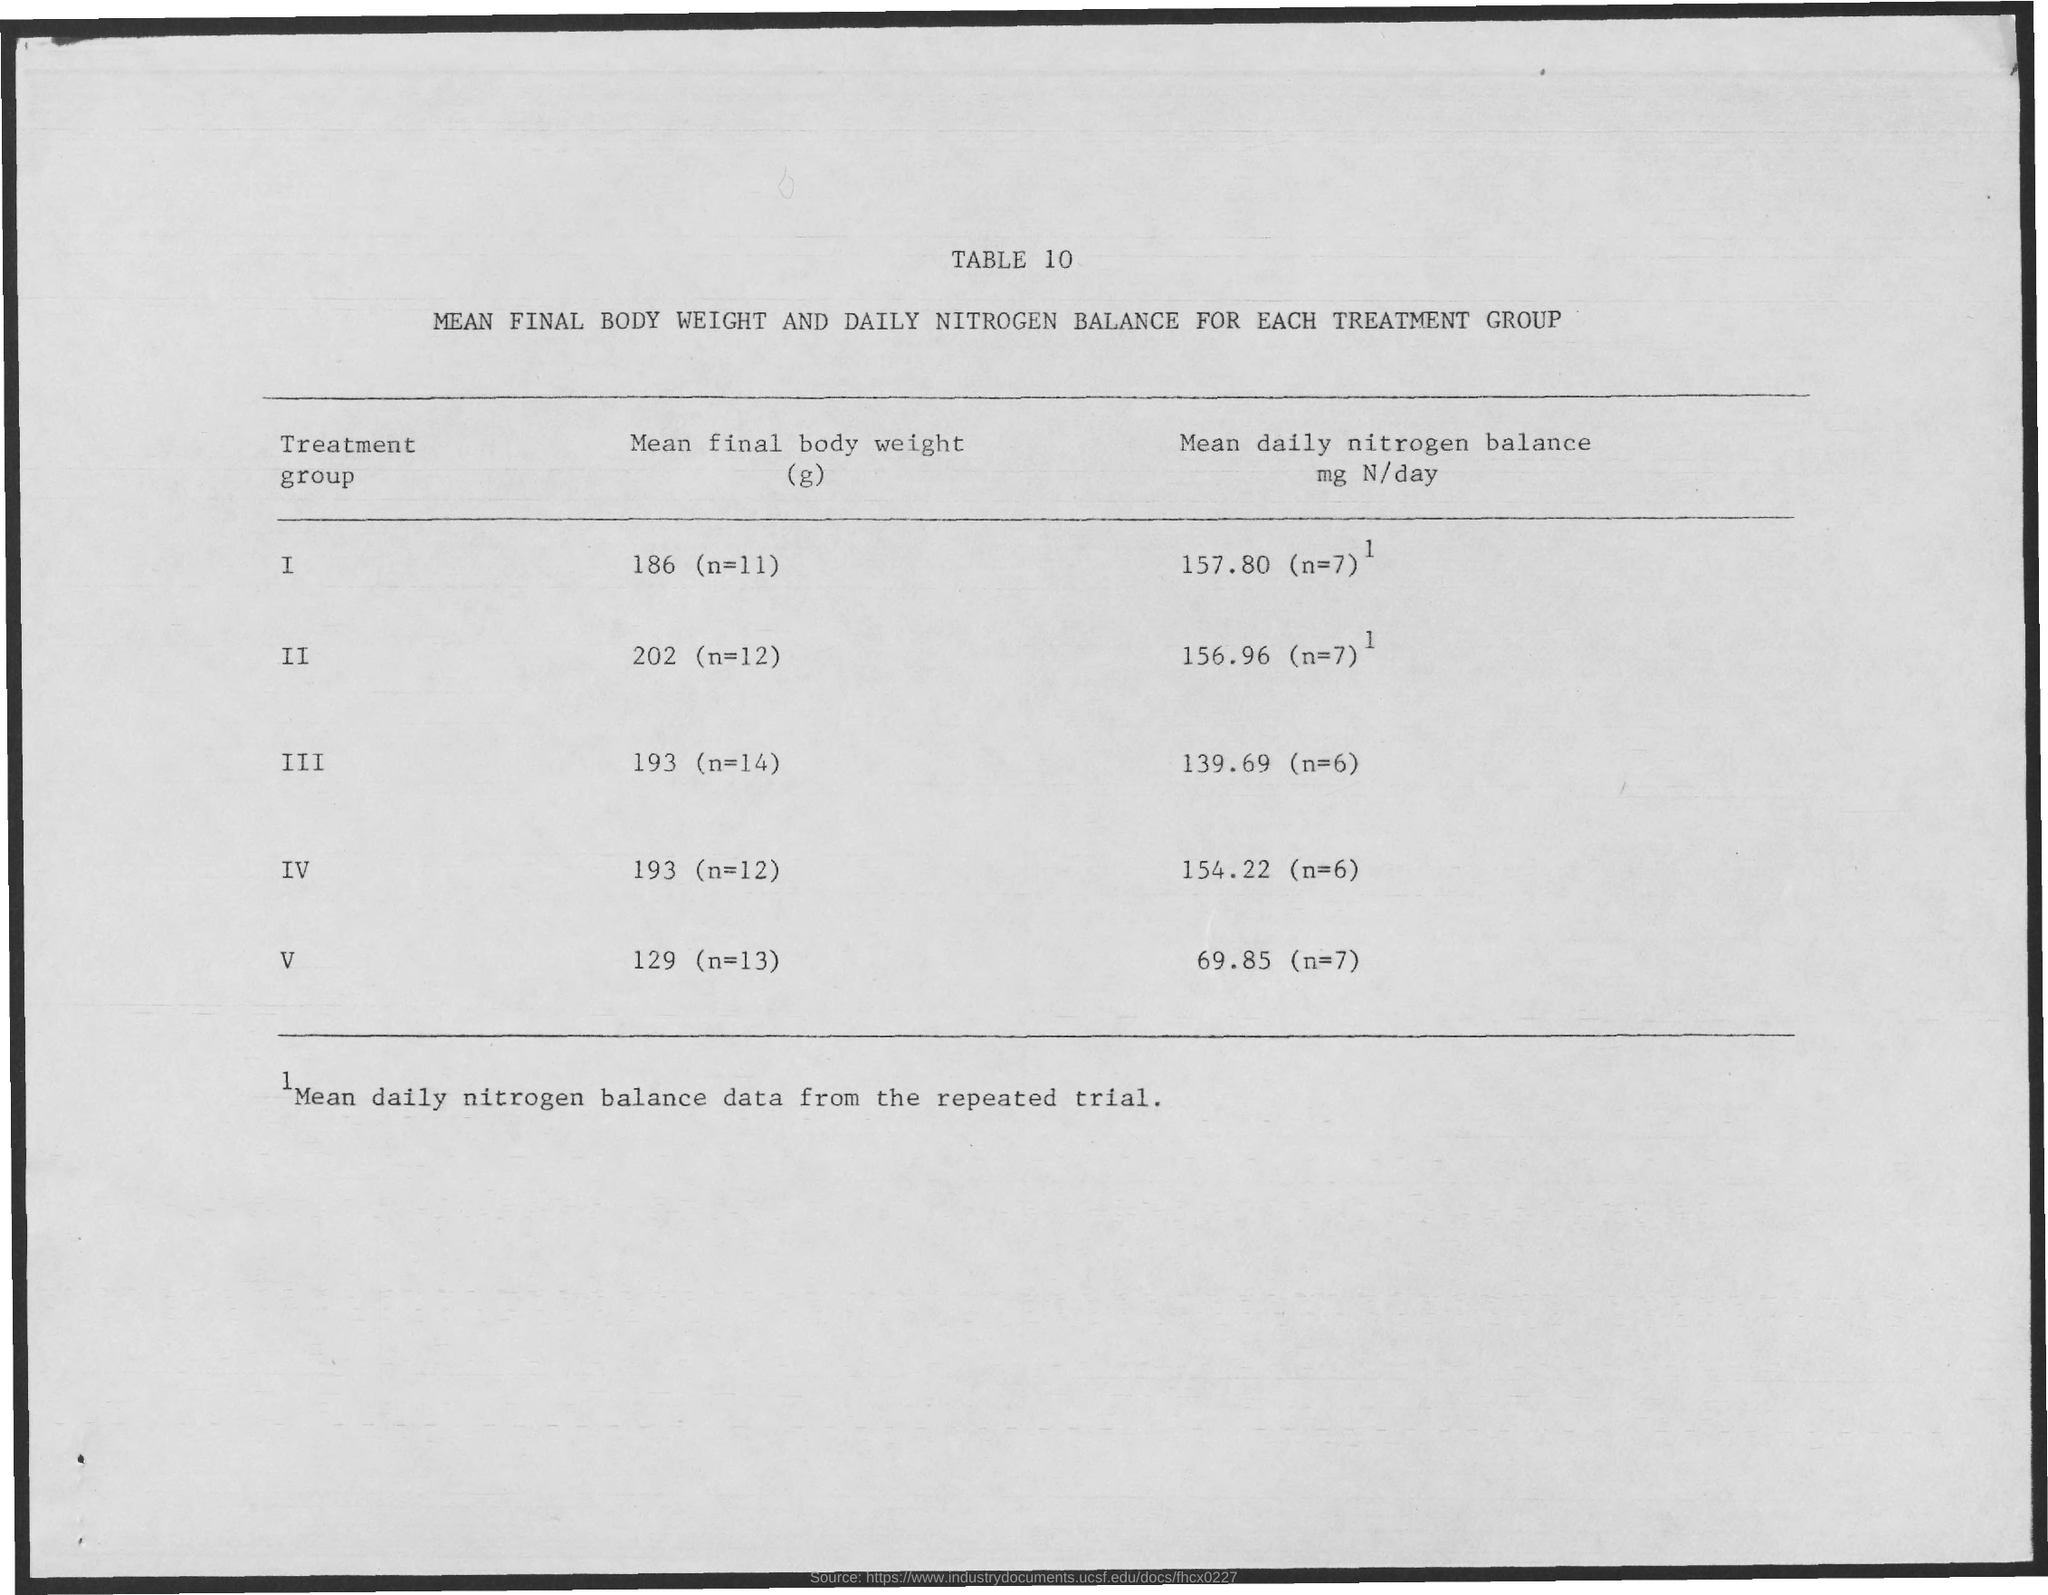How much is the mean final body weight of treatment group one?
Provide a short and direct response. 186 (n=11). 